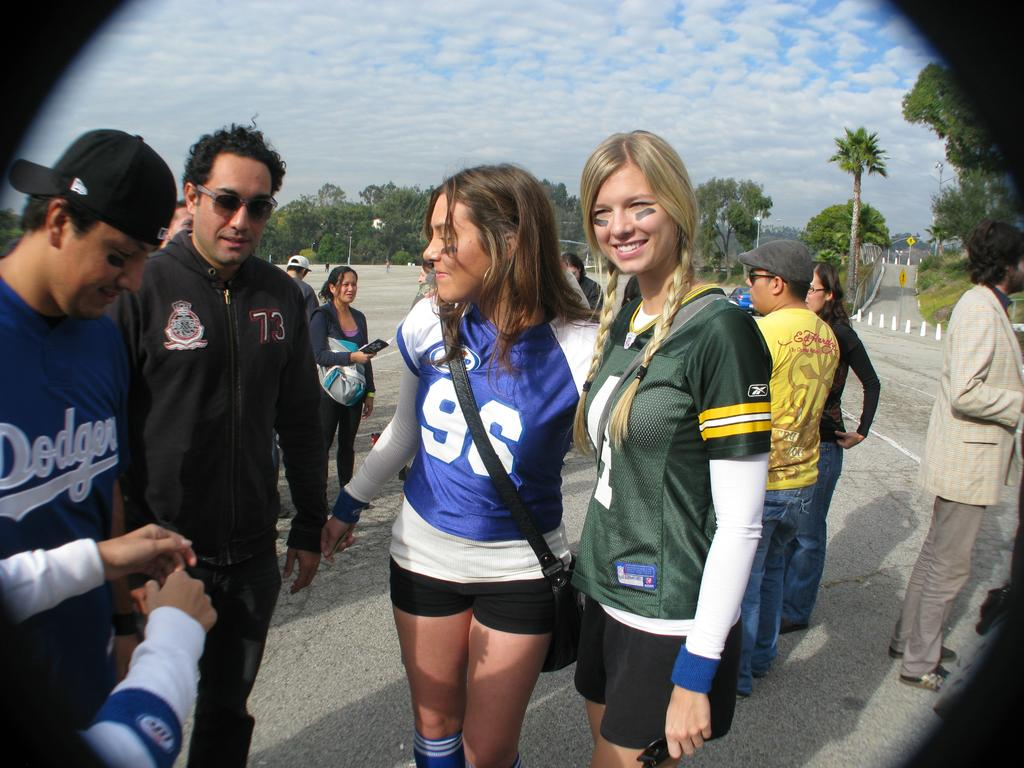<image>
Offer a succinct explanation of the picture presented. People are standing around wearing their favorite sports outfits including a  dodgers jersey. 